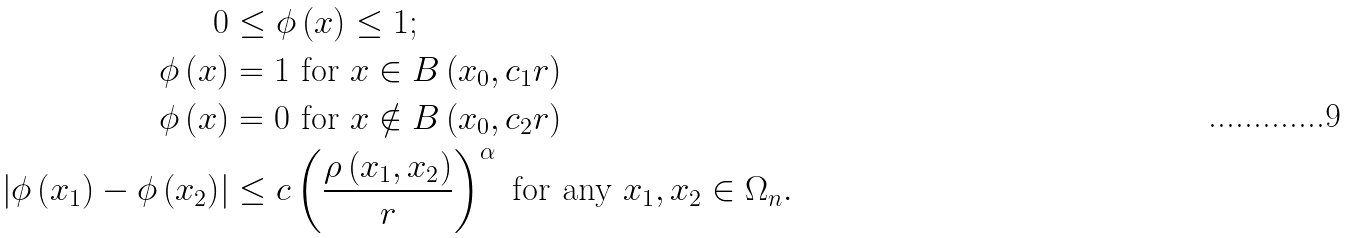<formula> <loc_0><loc_0><loc_500><loc_500>0 & \leq \phi \left ( x \right ) \leq 1 ; \\ \phi \left ( x \right ) & = 1 \text { for } x \in B \left ( x _ { 0 } , c _ { 1 } r \right ) \\ \phi \left ( x \right ) & = 0 \text { for } x \notin B \left ( x _ { 0 } , c _ { 2 } r \right ) \\ \left | \phi \left ( x _ { 1 } \right ) - \phi \left ( x _ { 2 } \right ) \right | & \leq c \left ( \frac { \rho \left ( x _ { 1 } , x _ { 2 } \right ) } { r } \right ) ^ { \alpha } \text { for any } x _ { 1 } , x _ { 2 } \in \Omega _ { n } .</formula> 